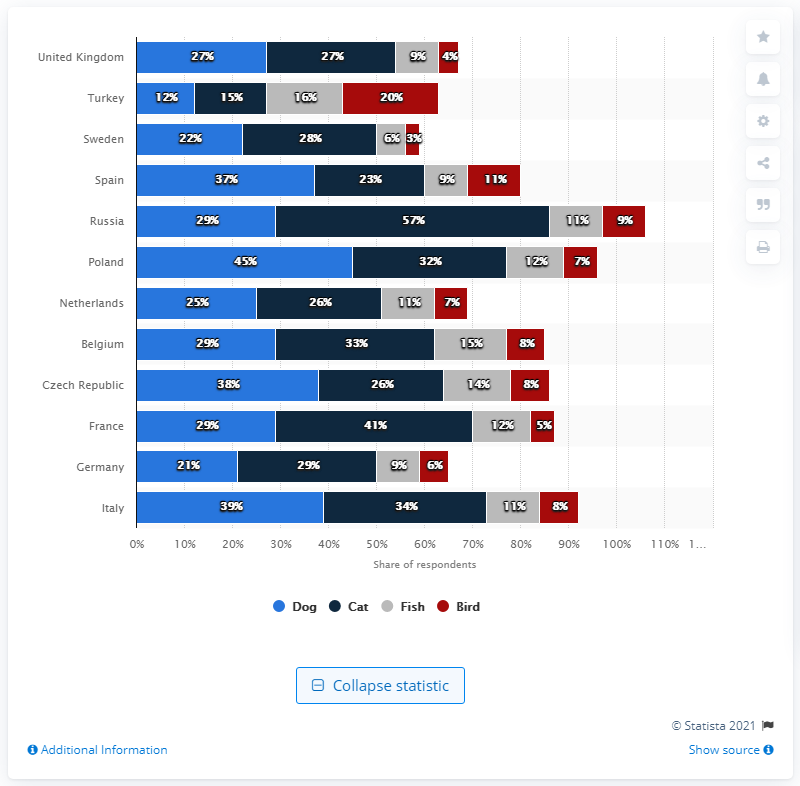What trends can we observe about pet ownership in European countries from this bar graph? The bar graph indicates a higher ownership of cats and dogs compared to fish and birds across European countries. Italy shows the highest dog ownership at 39%, while Russia stands out for the highest cat ownership at 57%. There's also notable variation in pet ownership between countries, suggesting cultural or socioeconomic differences. 